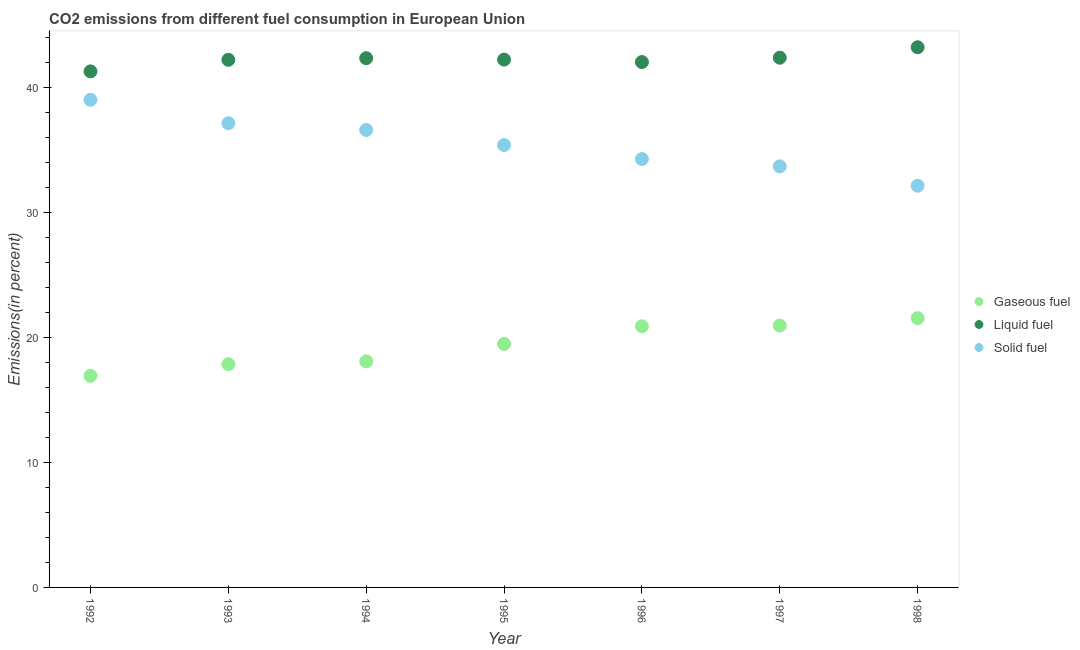What is the percentage of liquid fuel emission in 1992?
Offer a very short reply. 41.31. Across all years, what is the maximum percentage of solid fuel emission?
Make the answer very short. 39.03. Across all years, what is the minimum percentage of solid fuel emission?
Ensure brevity in your answer.  32.15. In which year was the percentage of solid fuel emission minimum?
Your answer should be compact. 1998. What is the total percentage of gaseous fuel emission in the graph?
Your response must be concise. 135.8. What is the difference between the percentage of liquid fuel emission in 1992 and that in 1994?
Your answer should be very brief. -1.06. What is the difference between the percentage of gaseous fuel emission in 1997 and the percentage of solid fuel emission in 1994?
Provide a short and direct response. -15.66. What is the average percentage of liquid fuel emission per year?
Provide a succinct answer. 42.26. In the year 1994, what is the difference between the percentage of liquid fuel emission and percentage of solid fuel emission?
Keep it short and to the point. 5.74. What is the ratio of the percentage of gaseous fuel emission in 1992 to that in 1993?
Your response must be concise. 0.95. What is the difference between the highest and the second highest percentage of solid fuel emission?
Give a very brief answer. 1.87. What is the difference between the highest and the lowest percentage of solid fuel emission?
Provide a succinct answer. 6.88. How many years are there in the graph?
Ensure brevity in your answer.  7. What is the difference between two consecutive major ticks on the Y-axis?
Offer a very short reply. 10. Are the values on the major ticks of Y-axis written in scientific E-notation?
Your answer should be very brief. No. How are the legend labels stacked?
Keep it short and to the point. Vertical. What is the title of the graph?
Offer a very short reply. CO2 emissions from different fuel consumption in European Union. Does "Social Protection" appear as one of the legend labels in the graph?
Provide a short and direct response. No. What is the label or title of the X-axis?
Make the answer very short. Year. What is the label or title of the Y-axis?
Offer a terse response. Emissions(in percent). What is the Emissions(in percent) in Gaseous fuel in 1992?
Give a very brief answer. 16.93. What is the Emissions(in percent) of Liquid fuel in 1992?
Make the answer very short. 41.31. What is the Emissions(in percent) in Solid fuel in 1992?
Give a very brief answer. 39.03. What is the Emissions(in percent) in Gaseous fuel in 1993?
Offer a very short reply. 17.87. What is the Emissions(in percent) of Liquid fuel in 1993?
Your response must be concise. 42.23. What is the Emissions(in percent) in Solid fuel in 1993?
Keep it short and to the point. 37.15. What is the Emissions(in percent) in Gaseous fuel in 1994?
Offer a very short reply. 18.09. What is the Emissions(in percent) in Liquid fuel in 1994?
Make the answer very short. 42.36. What is the Emissions(in percent) in Solid fuel in 1994?
Give a very brief answer. 36.62. What is the Emissions(in percent) in Gaseous fuel in 1995?
Your answer should be very brief. 19.49. What is the Emissions(in percent) in Liquid fuel in 1995?
Make the answer very short. 42.25. What is the Emissions(in percent) in Solid fuel in 1995?
Make the answer very short. 35.41. What is the Emissions(in percent) in Gaseous fuel in 1996?
Keep it short and to the point. 20.9. What is the Emissions(in percent) of Liquid fuel in 1996?
Ensure brevity in your answer.  42.05. What is the Emissions(in percent) of Solid fuel in 1996?
Make the answer very short. 34.29. What is the Emissions(in percent) in Gaseous fuel in 1997?
Your answer should be compact. 20.96. What is the Emissions(in percent) of Liquid fuel in 1997?
Your answer should be very brief. 42.4. What is the Emissions(in percent) of Solid fuel in 1997?
Provide a succinct answer. 33.7. What is the Emissions(in percent) of Gaseous fuel in 1998?
Keep it short and to the point. 21.56. What is the Emissions(in percent) in Liquid fuel in 1998?
Your answer should be compact. 43.24. What is the Emissions(in percent) of Solid fuel in 1998?
Your response must be concise. 32.15. Across all years, what is the maximum Emissions(in percent) in Gaseous fuel?
Make the answer very short. 21.56. Across all years, what is the maximum Emissions(in percent) in Liquid fuel?
Provide a short and direct response. 43.24. Across all years, what is the maximum Emissions(in percent) of Solid fuel?
Ensure brevity in your answer.  39.03. Across all years, what is the minimum Emissions(in percent) of Gaseous fuel?
Keep it short and to the point. 16.93. Across all years, what is the minimum Emissions(in percent) in Liquid fuel?
Keep it short and to the point. 41.31. Across all years, what is the minimum Emissions(in percent) in Solid fuel?
Offer a very short reply. 32.15. What is the total Emissions(in percent) of Gaseous fuel in the graph?
Make the answer very short. 135.8. What is the total Emissions(in percent) of Liquid fuel in the graph?
Offer a very short reply. 295.83. What is the total Emissions(in percent) of Solid fuel in the graph?
Provide a short and direct response. 248.35. What is the difference between the Emissions(in percent) of Gaseous fuel in 1992 and that in 1993?
Offer a terse response. -0.93. What is the difference between the Emissions(in percent) in Liquid fuel in 1992 and that in 1993?
Your answer should be very brief. -0.93. What is the difference between the Emissions(in percent) of Solid fuel in 1992 and that in 1993?
Your answer should be very brief. 1.87. What is the difference between the Emissions(in percent) of Gaseous fuel in 1992 and that in 1994?
Your response must be concise. -1.16. What is the difference between the Emissions(in percent) of Liquid fuel in 1992 and that in 1994?
Provide a short and direct response. -1.06. What is the difference between the Emissions(in percent) of Solid fuel in 1992 and that in 1994?
Your answer should be compact. 2.41. What is the difference between the Emissions(in percent) of Gaseous fuel in 1992 and that in 1995?
Keep it short and to the point. -2.56. What is the difference between the Emissions(in percent) in Liquid fuel in 1992 and that in 1995?
Give a very brief answer. -0.94. What is the difference between the Emissions(in percent) in Solid fuel in 1992 and that in 1995?
Provide a succinct answer. 3.62. What is the difference between the Emissions(in percent) of Gaseous fuel in 1992 and that in 1996?
Keep it short and to the point. -3.97. What is the difference between the Emissions(in percent) of Liquid fuel in 1992 and that in 1996?
Your response must be concise. -0.75. What is the difference between the Emissions(in percent) in Solid fuel in 1992 and that in 1996?
Provide a succinct answer. 4.74. What is the difference between the Emissions(in percent) in Gaseous fuel in 1992 and that in 1997?
Make the answer very short. -4.02. What is the difference between the Emissions(in percent) in Liquid fuel in 1992 and that in 1997?
Offer a very short reply. -1.09. What is the difference between the Emissions(in percent) in Solid fuel in 1992 and that in 1997?
Offer a terse response. 5.33. What is the difference between the Emissions(in percent) in Gaseous fuel in 1992 and that in 1998?
Your answer should be compact. -4.62. What is the difference between the Emissions(in percent) of Liquid fuel in 1992 and that in 1998?
Give a very brief answer. -1.93. What is the difference between the Emissions(in percent) in Solid fuel in 1992 and that in 1998?
Provide a short and direct response. 6.88. What is the difference between the Emissions(in percent) of Gaseous fuel in 1993 and that in 1994?
Offer a very short reply. -0.23. What is the difference between the Emissions(in percent) of Liquid fuel in 1993 and that in 1994?
Ensure brevity in your answer.  -0.13. What is the difference between the Emissions(in percent) in Solid fuel in 1993 and that in 1994?
Give a very brief answer. 0.54. What is the difference between the Emissions(in percent) in Gaseous fuel in 1993 and that in 1995?
Offer a terse response. -1.62. What is the difference between the Emissions(in percent) in Liquid fuel in 1993 and that in 1995?
Provide a short and direct response. -0.02. What is the difference between the Emissions(in percent) of Solid fuel in 1993 and that in 1995?
Offer a terse response. 1.75. What is the difference between the Emissions(in percent) in Gaseous fuel in 1993 and that in 1996?
Offer a terse response. -3.03. What is the difference between the Emissions(in percent) in Liquid fuel in 1993 and that in 1996?
Make the answer very short. 0.18. What is the difference between the Emissions(in percent) of Solid fuel in 1993 and that in 1996?
Your answer should be very brief. 2.86. What is the difference between the Emissions(in percent) in Gaseous fuel in 1993 and that in 1997?
Provide a short and direct response. -3.09. What is the difference between the Emissions(in percent) of Liquid fuel in 1993 and that in 1997?
Your answer should be compact. -0.17. What is the difference between the Emissions(in percent) in Solid fuel in 1993 and that in 1997?
Make the answer very short. 3.45. What is the difference between the Emissions(in percent) in Gaseous fuel in 1993 and that in 1998?
Your answer should be very brief. -3.69. What is the difference between the Emissions(in percent) in Liquid fuel in 1993 and that in 1998?
Your answer should be very brief. -1. What is the difference between the Emissions(in percent) of Solid fuel in 1993 and that in 1998?
Offer a very short reply. 5. What is the difference between the Emissions(in percent) of Gaseous fuel in 1994 and that in 1995?
Make the answer very short. -1.39. What is the difference between the Emissions(in percent) in Liquid fuel in 1994 and that in 1995?
Offer a very short reply. 0.11. What is the difference between the Emissions(in percent) in Solid fuel in 1994 and that in 1995?
Offer a very short reply. 1.21. What is the difference between the Emissions(in percent) of Gaseous fuel in 1994 and that in 1996?
Keep it short and to the point. -2.8. What is the difference between the Emissions(in percent) in Liquid fuel in 1994 and that in 1996?
Ensure brevity in your answer.  0.31. What is the difference between the Emissions(in percent) in Solid fuel in 1994 and that in 1996?
Offer a very short reply. 2.33. What is the difference between the Emissions(in percent) of Gaseous fuel in 1994 and that in 1997?
Offer a terse response. -2.86. What is the difference between the Emissions(in percent) of Liquid fuel in 1994 and that in 1997?
Offer a very short reply. -0.04. What is the difference between the Emissions(in percent) in Solid fuel in 1994 and that in 1997?
Offer a very short reply. 2.91. What is the difference between the Emissions(in percent) of Gaseous fuel in 1994 and that in 1998?
Provide a short and direct response. -3.46. What is the difference between the Emissions(in percent) in Liquid fuel in 1994 and that in 1998?
Provide a succinct answer. -0.87. What is the difference between the Emissions(in percent) in Solid fuel in 1994 and that in 1998?
Provide a short and direct response. 4.46. What is the difference between the Emissions(in percent) in Gaseous fuel in 1995 and that in 1996?
Give a very brief answer. -1.41. What is the difference between the Emissions(in percent) in Liquid fuel in 1995 and that in 1996?
Your answer should be compact. 0.2. What is the difference between the Emissions(in percent) of Solid fuel in 1995 and that in 1996?
Provide a succinct answer. 1.12. What is the difference between the Emissions(in percent) in Gaseous fuel in 1995 and that in 1997?
Your answer should be very brief. -1.47. What is the difference between the Emissions(in percent) in Liquid fuel in 1995 and that in 1997?
Provide a short and direct response. -0.15. What is the difference between the Emissions(in percent) in Solid fuel in 1995 and that in 1997?
Make the answer very short. 1.7. What is the difference between the Emissions(in percent) of Gaseous fuel in 1995 and that in 1998?
Provide a succinct answer. -2.07. What is the difference between the Emissions(in percent) in Liquid fuel in 1995 and that in 1998?
Offer a very short reply. -0.99. What is the difference between the Emissions(in percent) in Solid fuel in 1995 and that in 1998?
Give a very brief answer. 3.25. What is the difference between the Emissions(in percent) of Gaseous fuel in 1996 and that in 1997?
Your answer should be compact. -0.06. What is the difference between the Emissions(in percent) of Liquid fuel in 1996 and that in 1997?
Offer a very short reply. -0.35. What is the difference between the Emissions(in percent) in Solid fuel in 1996 and that in 1997?
Your answer should be compact. 0.59. What is the difference between the Emissions(in percent) of Gaseous fuel in 1996 and that in 1998?
Give a very brief answer. -0.66. What is the difference between the Emissions(in percent) of Liquid fuel in 1996 and that in 1998?
Your answer should be compact. -1.18. What is the difference between the Emissions(in percent) of Solid fuel in 1996 and that in 1998?
Offer a terse response. 2.14. What is the difference between the Emissions(in percent) of Gaseous fuel in 1997 and that in 1998?
Your answer should be compact. -0.6. What is the difference between the Emissions(in percent) of Liquid fuel in 1997 and that in 1998?
Provide a succinct answer. -0.84. What is the difference between the Emissions(in percent) in Solid fuel in 1997 and that in 1998?
Make the answer very short. 1.55. What is the difference between the Emissions(in percent) in Gaseous fuel in 1992 and the Emissions(in percent) in Liquid fuel in 1993?
Offer a terse response. -25.3. What is the difference between the Emissions(in percent) in Gaseous fuel in 1992 and the Emissions(in percent) in Solid fuel in 1993?
Provide a short and direct response. -20.22. What is the difference between the Emissions(in percent) of Liquid fuel in 1992 and the Emissions(in percent) of Solid fuel in 1993?
Give a very brief answer. 4.15. What is the difference between the Emissions(in percent) in Gaseous fuel in 1992 and the Emissions(in percent) in Liquid fuel in 1994?
Your answer should be compact. -25.43. What is the difference between the Emissions(in percent) of Gaseous fuel in 1992 and the Emissions(in percent) of Solid fuel in 1994?
Your answer should be very brief. -19.68. What is the difference between the Emissions(in percent) of Liquid fuel in 1992 and the Emissions(in percent) of Solid fuel in 1994?
Your answer should be compact. 4.69. What is the difference between the Emissions(in percent) in Gaseous fuel in 1992 and the Emissions(in percent) in Liquid fuel in 1995?
Your answer should be compact. -25.31. What is the difference between the Emissions(in percent) in Gaseous fuel in 1992 and the Emissions(in percent) in Solid fuel in 1995?
Offer a very short reply. -18.47. What is the difference between the Emissions(in percent) in Liquid fuel in 1992 and the Emissions(in percent) in Solid fuel in 1995?
Ensure brevity in your answer.  5.9. What is the difference between the Emissions(in percent) in Gaseous fuel in 1992 and the Emissions(in percent) in Liquid fuel in 1996?
Your answer should be very brief. -25.12. What is the difference between the Emissions(in percent) of Gaseous fuel in 1992 and the Emissions(in percent) of Solid fuel in 1996?
Offer a terse response. -17.36. What is the difference between the Emissions(in percent) in Liquid fuel in 1992 and the Emissions(in percent) in Solid fuel in 1996?
Ensure brevity in your answer.  7.01. What is the difference between the Emissions(in percent) of Gaseous fuel in 1992 and the Emissions(in percent) of Liquid fuel in 1997?
Provide a short and direct response. -25.47. What is the difference between the Emissions(in percent) in Gaseous fuel in 1992 and the Emissions(in percent) in Solid fuel in 1997?
Keep it short and to the point. -16.77. What is the difference between the Emissions(in percent) of Liquid fuel in 1992 and the Emissions(in percent) of Solid fuel in 1997?
Your answer should be compact. 7.6. What is the difference between the Emissions(in percent) in Gaseous fuel in 1992 and the Emissions(in percent) in Liquid fuel in 1998?
Your answer should be very brief. -26.3. What is the difference between the Emissions(in percent) of Gaseous fuel in 1992 and the Emissions(in percent) of Solid fuel in 1998?
Offer a terse response. -15.22. What is the difference between the Emissions(in percent) in Liquid fuel in 1992 and the Emissions(in percent) in Solid fuel in 1998?
Provide a succinct answer. 9.15. What is the difference between the Emissions(in percent) of Gaseous fuel in 1993 and the Emissions(in percent) of Liquid fuel in 1994?
Your answer should be compact. -24.49. What is the difference between the Emissions(in percent) of Gaseous fuel in 1993 and the Emissions(in percent) of Solid fuel in 1994?
Your response must be concise. -18.75. What is the difference between the Emissions(in percent) in Liquid fuel in 1993 and the Emissions(in percent) in Solid fuel in 1994?
Ensure brevity in your answer.  5.62. What is the difference between the Emissions(in percent) in Gaseous fuel in 1993 and the Emissions(in percent) in Liquid fuel in 1995?
Give a very brief answer. -24.38. What is the difference between the Emissions(in percent) in Gaseous fuel in 1993 and the Emissions(in percent) in Solid fuel in 1995?
Provide a succinct answer. -17.54. What is the difference between the Emissions(in percent) of Liquid fuel in 1993 and the Emissions(in percent) of Solid fuel in 1995?
Keep it short and to the point. 6.82. What is the difference between the Emissions(in percent) in Gaseous fuel in 1993 and the Emissions(in percent) in Liquid fuel in 1996?
Provide a succinct answer. -24.18. What is the difference between the Emissions(in percent) in Gaseous fuel in 1993 and the Emissions(in percent) in Solid fuel in 1996?
Your answer should be very brief. -16.42. What is the difference between the Emissions(in percent) in Liquid fuel in 1993 and the Emissions(in percent) in Solid fuel in 1996?
Offer a terse response. 7.94. What is the difference between the Emissions(in percent) of Gaseous fuel in 1993 and the Emissions(in percent) of Liquid fuel in 1997?
Keep it short and to the point. -24.53. What is the difference between the Emissions(in percent) in Gaseous fuel in 1993 and the Emissions(in percent) in Solid fuel in 1997?
Make the answer very short. -15.83. What is the difference between the Emissions(in percent) in Liquid fuel in 1993 and the Emissions(in percent) in Solid fuel in 1997?
Give a very brief answer. 8.53. What is the difference between the Emissions(in percent) in Gaseous fuel in 1993 and the Emissions(in percent) in Liquid fuel in 1998?
Offer a very short reply. -25.37. What is the difference between the Emissions(in percent) in Gaseous fuel in 1993 and the Emissions(in percent) in Solid fuel in 1998?
Provide a succinct answer. -14.29. What is the difference between the Emissions(in percent) in Liquid fuel in 1993 and the Emissions(in percent) in Solid fuel in 1998?
Offer a terse response. 10.08. What is the difference between the Emissions(in percent) of Gaseous fuel in 1994 and the Emissions(in percent) of Liquid fuel in 1995?
Provide a succinct answer. -24.15. What is the difference between the Emissions(in percent) in Gaseous fuel in 1994 and the Emissions(in percent) in Solid fuel in 1995?
Keep it short and to the point. -17.31. What is the difference between the Emissions(in percent) of Liquid fuel in 1994 and the Emissions(in percent) of Solid fuel in 1995?
Offer a terse response. 6.95. What is the difference between the Emissions(in percent) in Gaseous fuel in 1994 and the Emissions(in percent) in Liquid fuel in 1996?
Your answer should be compact. -23.96. What is the difference between the Emissions(in percent) of Gaseous fuel in 1994 and the Emissions(in percent) of Solid fuel in 1996?
Ensure brevity in your answer.  -16.2. What is the difference between the Emissions(in percent) in Liquid fuel in 1994 and the Emissions(in percent) in Solid fuel in 1996?
Keep it short and to the point. 8.07. What is the difference between the Emissions(in percent) of Gaseous fuel in 1994 and the Emissions(in percent) of Liquid fuel in 1997?
Ensure brevity in your answer.  -24.31. What is the difference between the Emissions(in percent) of Gaseous fuel in 1994 and the Emissions(in percent) of Solid fuel in 1997?
Your response must be concise. -15.61. What is the difference between the Emissions(in percent) in Liquid fuel in 1994 and the Emissions(in percent) in Solid fuel in 1997?
Provide a succinct answer. 8.66. What is the difference between the Emissions(in percent) of Gaseous fuel in 1994 and the Emissions(in percent) of Liquid fuel in 1998?
Make the answer very short. -25.14. What is the difference between the Emissions(in percent) in Gaseous fuel in 1994 and the Emissions(in percent) in Solid fuel in 1998?
Provide a short and direct response. -14.06. What is the difference between the Emissions(in percent) of Liquid fuel in 1994 and the Emissions(in percent) of Solid fuel in 1998?
Provide a succinct answer. 10.21. What is the difference between the Emissions(in percent) of Gaseous fuel in 1995 and the Emissions(in percent) of Liquid fuel in 1996?
Ensure brevity in your answer.  -22.56. What is the difference between the Emissions(in percent) in Gaseous fuel in 1995 and the Emissions(in percent) in Solid fuel in 1996?
Keep it short and to the point. -14.8. What is the difference between the Emissions(in percent) in Liquid fuel in 1995 and the Emissions(in percent) in Solid fuel in 1996?
Keep it short and to the point. 7.96. What is the difference between the Emissions(in percent) of Gaseous fuel in 1995 and the Emissions(in percent) of Liquid fuel in 1997?
Offer a terse response. -22.91. What is the difference between the Emissions(in percent) in Gaseous fuel in 1995 and the Emissions(in percent) in Solid fuel in 1997?
Give a very brief answer. -14.21. What is the difference between the Emissions(in percent) of Liquid fuel in 1995 and the Emissions(in percent) of Solid fuel in 1997?
Your answer should be compact. 8.55. What is the difference between the Emissions(in percent) of Gaseous fuel in 1995 and the Emissions(in percent) of Liquid fuel in 1998?
Make the answer very short. -23.75. What is the difference between the Emissions(in percent) in Gaseous fuel in 1995 and the Emissions(in percent) in Solid fuel in 1998?
Make the answer very short. -12.66. What is the difference between the Emissions(in percent) in Liquid fuel in 1995 and the Emissions(in percent) in Solid fuel in 1998?
Your answer should be compact. 10.09. What is the difference between the Emissions(in percent) of Gaseous fuel in 1996 and the Emissions(in percent) of Liquid fuel in 1997?
Offer a terse response. -21.5. What is the difference between the Emissions(in percent) of Gaseous fuel in 1996 and the Emissions(in percent) of Solid fuel in 1997?
Ensure brevity in your answer.  -12.8. What is the difference between the Emissions(in percent) in Liquid fuel in 1996 and the Emissions(in percent) in Solid fuel in 1997?
Offer a very short reply. 8.35. What is the difference between the Emissions(in percent) in Gaseous fuel in 1996 and the Emissions(in percent) in Liquid fuel in 1998?
Give a very brief answer. -22.34. What is the difference between the Emissions(in percent) in Gaseous fuel in 1996 and the Emissions(in percent) in Solid fuel in 1998?
Your response must be concise. -11.25. What is the difference between the Emissions(in percent) of Liquid fuel in 1996 and the Emissions(in percent) of Solid fuel in 1998?
Your answer should be very brief. 9.9. What is the difference between the Emissions(in percent) in Gaseous fuel in 1997 and the Emissions(in percent) in Liquid fuel in 1998?
Your answer should be very brief. -22.28. What is the difference between the Emissions(in percent) in Gaseous fuel in 1997 and the Emissions(in percent) in Solid fuel in 1998?
Provide a short and direct response. -11.2. What is the difference between the Emissions(in percent) in Liquid fuel in 1997 and the Emissions(in percent) in Solid fuel in 1998?
Provide a short and direct response. 10.25. What is the average Emissions(in percent) in Gaseous fuel per year?
Provide a succinct answer. 19.4. What is the average Emissions(in percent) of Liquid fuel per year?
Give a very brief answer. 42.26. What is the average Emissions(in percent) of Solid fuel per year?
Your answer should be compact. 35.48. In the year 1992, what is the difference between the Emissions(in percent) of Gaseous fuel and Emissions(in percent) of Liquid fuel?
Your answer should be compact. -24.37. In the year 1992, what is the difference between the Emissions(in percent) in Gaseous fuel and Emissions(in percent) in Solid fuel?
Provide a succinct answer. -22.09. In the year 1992, what is the difference between the Emissions(in percent) in Liquid fuel and Emissions(in percent) in Solid fuel?
Your response must be concise. 2.28. In the year 1993, what is the difference between the Emissions(in percent) of Gaseous fuel and Emissions(in percent) of Liquid fuel?
Make the answer very short. -24.36. In the year 1993, what is the difference between the Emissions(in percent) of Gaseous fuel and Emissions(in percent) of Solid fuel?
Offer a terse response. -19.29. In the year 1993, what is the difference between the Emissions(in percent) of Liquid fuel and Emissions(in percent) of Solid fuel?
Make the answer very short. 5.08. In the year 1994, what is the difference between the Emissions(in percent) of Gaseous fuel and Emissions(in percent) of Liquid fuel?
Make the answer very short. -24.27. In the year 1994, what is the difference between the Emissions(in percent) of Gaseous fuel and Emissions(in percent) of Solid fuel?
Provide a short and direct response. -18.52. In the year 1994, what is the difference between the Emissions(in percent) in Liquid fuel and Emissions(in percent) in Solid fuel?
Offer a very short reply. 5.74. In the year 1995, what is the difference between the Emissions(in percent) of Gaseous fuel and Emissions(in percent) of Liquid fuel?
Provide a short and direct response. -22.76. In the year 1995, what is the difference between the Emissions(in percent) in Gaseous fuel and Emissions(in percent) in Solid fuel?
Give a very brief answer. -15.92. In the year 1995, what is the difference between the Emissions(in percent) in Liquid fuel and Emissions(in percent) in Solid fuel?
Give a very brief answer. 6.84. In the year 1996, what is the difference between the Emissions(in percent) of Gaseous fuel and Emissions(in percent) of Liquid fuel?
Provide a succinct answer. -21.15. In the year 1996, what is the difference between the Emissions(in percent) in Gaseous fuel and Emissions(in percent) in Solid fuel?
Make the answer very short. -13.39. In the year 1996, what is the difference between the Emissions(in percent) in Liquid fuel and Emissions(in percent) in Solid fuel?
Offer a very short reply. 7.76. In the year 1997, what is the difference between the Emissions(in percent) in Gaseous fuel and Emissions(in percent) in Liquid fuel?
Keep it short and to the point. -21.44. In the year 1997, what is the difference between the Emissions(in percent) of Gaseous fuel and Emissions(in percent) of Solid fuel?
Offer a terse response. -12.74. In the year 1997, what is the difference between the Emissions(in percent) of Liquid fuel and Emissions(in percent) of Solid fuel?
Give a very brief answer. 8.7. In the year 1998, what is the difference between the Emissions(in percent) of Gaseous fuel and Emissions(in percent) of Liquid fuel?
Provide a succinct answer. -21.68. In the year 1998, what is the difference between the Emissions(in percent) in Gaseous fuel and Emissions(in percent) in Solid fuel?
Your response must be concise. -10.6. In the year 1998, what is the difference between the Emissions(in percent) of Liquid fuel and Emissions(in percent) of Solid fuel?
Ensure brevity in your answer.  11.08. What is the ratio of the Emissions(in percent) in Gaseous fuel in 1992 to that in 1993?
Give a very brief answer. 0.95. What is the ratio of the Emissions(in percent) of Liquid fuel in 1992 to that in 1993?
Keep it short and to the point. 0.98. What is the ratio of the Emissions(in percent) of Solid fuel in 1992 to that in 1993?
Your answer should be compact. 1.05. What is the ratio of the Emissions(in percent) in Gaseous fuel in 1992 to that in 1994?
Ensure brevity in your answer.  0.94. What is the ratio of the Emissions(in percent) in Liquid fuel in 1992 to that in 1994?
Keep it short and to the point. 0.98. What is the ratio of the Emissions(in percent) of Solid fuel in 1992 to that in 1994?
Ensure brevity in your answer.  1.07. What is the ratio of the Emissions(in percent) of Gaseous fuel in 1992 to that in 1995?
Keep it short and to the point. 0.87. What is the ratio of the Emissions(in percent) in Liquid fuel in 1992 to that in 1995?
Provide a short and direct response. 0.98. What is the ratio of the Emissions(in percent) of Solid fuel in 1992 to that in 1995?
Your answer should be very brief. 1.1. What is the ratio of the Emissions(in percent) of Gaseous fuel in 1992 to that in 1996?
Provide a short and direct response. 0.81. What is the ratio of the Emissions(in percent) in Liquid fuel in 1992 to that in 1996?
Your answer should be compact. 0.98. What is the ratio of the Emissions(in percent) of Solid fuel in 1992 to that in 1996?
Make the answer very short. 1.14. What is the ratio of the Emissions(in percent) in Gaseous fuel in 1992 to that in 1997?
Give a very brief answer. 0.81. What is the ratio of the Emissions(in percent) in Liquid fuel in 1992 to that in 1997?
Give a very brief answer. 0.97. What is the ratio of the Emissions(in percent) of Solid fuel in 1992 to that in 1997?
Ensure brevity in your answer.  1.16. What is the ratio of the Emissions(in percent) in Gaseous fuel in 1992 to that in 1998?
Offer a very short reply. 0.79. What is the ratio of the Emissions(in percent) of Liquid fuel in 1992 to that in 1998?
Make the answer very short. 0.96. What is the ratio of the Emissions(in percent) of Solid fuel in 1992 to that in 1998?
Your answer should be compact. 1.21. What is the ratio of the Emissions(in percent) of Gaseous fuel in 1993 to that in 1994?
Give a very brief answer. 0.99. What is the ratio of the Emissions(in percent) of Liquid fuel in 1993 to that in 1994?
Your answer should be compact. 1. What is the ratio of the Emissions(in percent) of Solid fuel in 1993 to that in 1994?
Provide a short and direct response. 1.01. What is the ratio of the Emissions(in percent) of Gaseous fuel in 1993 to that in 1995?
Give a very brief answer. 0.92. What is the ratio of the Emissions(in percent) in Liquid fuel in 1993 to that in 1995?
Keep it short and to the point. 1. What is the ratio of the Emissions(in percent) of Solid fuel in 1993 to that in 1995?
Keep it short and to the point. 1.05. What is the ratio of the Emissions(in percent) of Gaseous fuel in 1993 to that in 1996?
Your answer should be compact. 0.85. What is the ratio of the Emissions(in percent) in Solid fuel in 1993 to that in 1996?
Keep it short and to the point. 1.08. What is the ratio of the Emissions(in percent) of Gaseous fuel in 1993 to that in 1997?
Give a very brief answer. 0.85. What is the ratio of the Emissions(in percent) of Solid fuel in 1993 to that in 1997?
Offer a terse response. 1.1. What is the ratio of the Emissions(in percent) in Gaseous fuel in 1993 to that in 1998?
Your answer should be very brief. 0.83. What is the ratio of the Emissions(in percent) of Liquid fuel in 1993 to that in 1998?
Your answer should be very brief. 0.98. What is the ratio of the Emissions(in percent) of Solid fuel in 1993 to that in 1998?
Your answer should be very brief. 1.16. What is the ratio of the Emissions(in percent) in Gaseous fuel in 1994 to that in 1995?
Offer a very short reply. 0.93. What is the ratio of the Emissions(in percent) in Solid fuel in 1994 to that in 1995?
Ensure brevity in your answer.  1.03. What is the ratio of the Emissions(in percent) in Gaseous fuel in 1994 to that in 1996?
Provide a succinct answer. 0.87. What is the ratio of the Emissions(in percent) in Liquid fuel in 1994 to that in 1996?
Provide a succinct answer. 1.01. What is the ratio of the Emissions(in percent) of Solid fuel in 1994 to that in 1996?
Offer a terse response. 1.07. What is the ratio of the Emissions(in percent) in Gaseous fuel in 1994 to that in 1997?
Your answer should be very brief. 0.86. What is the ratio of the Emissions(in percent) in Solid fuel in 1994 to that in 1997?
Make the answer very short. 1.09. What is the ratio of the Emissions(in percent) of Gaseous fuel in 1994 to that in 1998?
Make the answer very short. 0.84. What is the ratio of the Emissions(in percent) in Liquid fuel in 1994 to that in 1998?
Make the answer very short. 0.98. What is the ratio of the Emissions(in percent) in Solid fuel in 1994 to that in 1998?
Your answer should be very brief. 1.14. What is the ratio of the Emissions(in percent) of Gaseous fuel in 1995 to that in 1996?
Give a very brief answer. 0.93. What is the ratio of the Emissions(in percent) of Solid fuel in 1995 to that in 1996?
Provide a succinct answer. 1.03. What is the ratio of the Emissions(in percent) in Gaseous fuel in 1995 to that in 1997?
Your answer should be compact. 0.93. What is the ratio of the Emissions(in percent) in Liquid fuel in 1995 to that in 1997?
Provide a short and direct response. 1. What is the ratio of the Emissions(in percent) of Solid fuel in 1995 to that in 1997?
Make the answer very short. 1.05. What is the ratio of the Emissions(in percent) in Gaseous fuel in 1995 to that in 1998?
Make the answer very short. 0.9. What is the ratio of the Emissions(in percent) of Liquid fuel in 1995 to that in 1998?
Offer a very short reply. 0.98. What is the ratio of the Emissions(in percent) of Solid fuel in 1995 to that in 1998?
Offer a very short reply. 1.1. What is the ratio of the Emissions(in percent) of Gaseous fuel in 1996 to that in 1997?
Your answer should be compact. 1. What is the ratio of the Emissions(in percent) of Solid fuel in 1996 to that in 1997?
Your answer should be very brief. 1.02. What is the ratio of the Emissions(in percent) of Gaseous fuel in 1996 to that in 1998?
Ensure brevity in your answer.  0.97. What is the ratio of the Emissions(in percent) of Liquid fuel in 1996 to that in 1998?
Offer a very short reply. 0.97. What is the ratio of the Emissions(in percent) of Solid fuel in 1996 to that in 1998?
Your response must be concise. 1.07. What is the ratio of the Emissions(in percent) of Gaseous fuel in 1997 to that in 1998?
Your response must be concise. 0.97. What is the ratio of the Emissions(in percent) in Liquid fuel in 1997 to that in 1998?
Give a very brief answer. 0.98. What is the ratio of the Emissions(in percent) in Solid fuel in 1997 to that in 1998?
Provide a short and direct response. 1.05. What is the difference between the highest and the second highest Emissions(in percent) in Gaseous fuel?
Give a very brief answer. 0.6. What is the difference between the highest and the second highest Emissions(in percent) of Liquid fuel?
Offer a terse response. 0.84. What is the difference between the highest and the second highest Emissions(in percent) in Solid fuel?
Your answer should be very brief. 1.87. What is the difference between the highest and the lowest Emissions(in percent) in Gaseous fuel?
Offer a very short reply. 4.62. What is the difference between the highest and the lowest Emissions(in percent) of Liquid fuel?
Your answer should be very brief. 1.93. What is the difference between the highest and the lowest Emissions(in percent) of Solid fuel?
Offer a terse response. 6.88. 